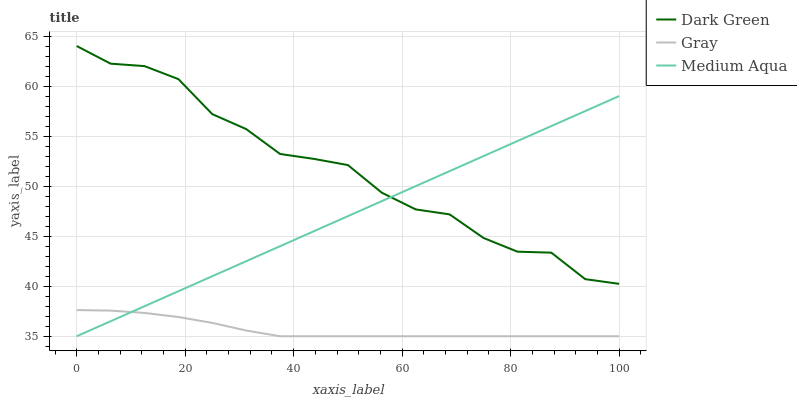Does Gray have the minimum area under the curve?
Answer yes or no. Yes. Does Dark Green have the maximum area under the curve?
Answer yes or no. Yes. Does Medium Aqua have the minimum area under the curve?
Answer yes or no. No. Does Medium Aqua have the maximum area under the curve?
Answer yes or no. No. Is Medium Aqua the smoothest?
Answer yes or no. Yes. Is Dark Green the roughest?
Answer yes or no. Yes. Is Dark Green the smoothest?
Answer yes or no. No. Is Medium Aqua the roughest?
Answer yes or no. No. Does Gray have the lowest value?
Answer yes or no. Yes. Does Dark Green have the lowest value?
Answer yes or no. No. Does Dark Green have the highest value?
Answer yes or no. Yes. Does Medium Aqua have the highest value?
Answer yes or no. No. Is Gray less than Dark Green?
Answer yes or no. Yes. Is Dark Green greater than Gray?
Answer yes or no. Yes. Does Medium Aqua intersect Dark Green?
Answer yes or no. Yes. Is Medium Aqua less than Dark Green?
Answer yes or no. No. Is Medium Aqua greater than Dark Green?
Answer yes or no. No. Does Gray intersect Dark Green?
Answer yes or no. No. 